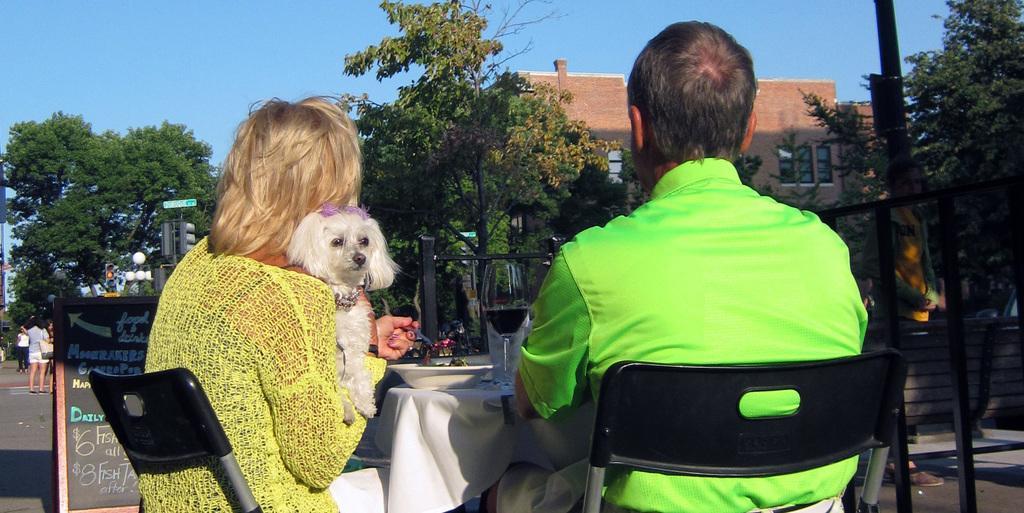Can you describe this image briefly? The women in the left is holding a dog in one of her hand and holding a spoon in her other hand and there is other person sitting beside her and there is a table in front of them and there are trees and buildings in the background. 